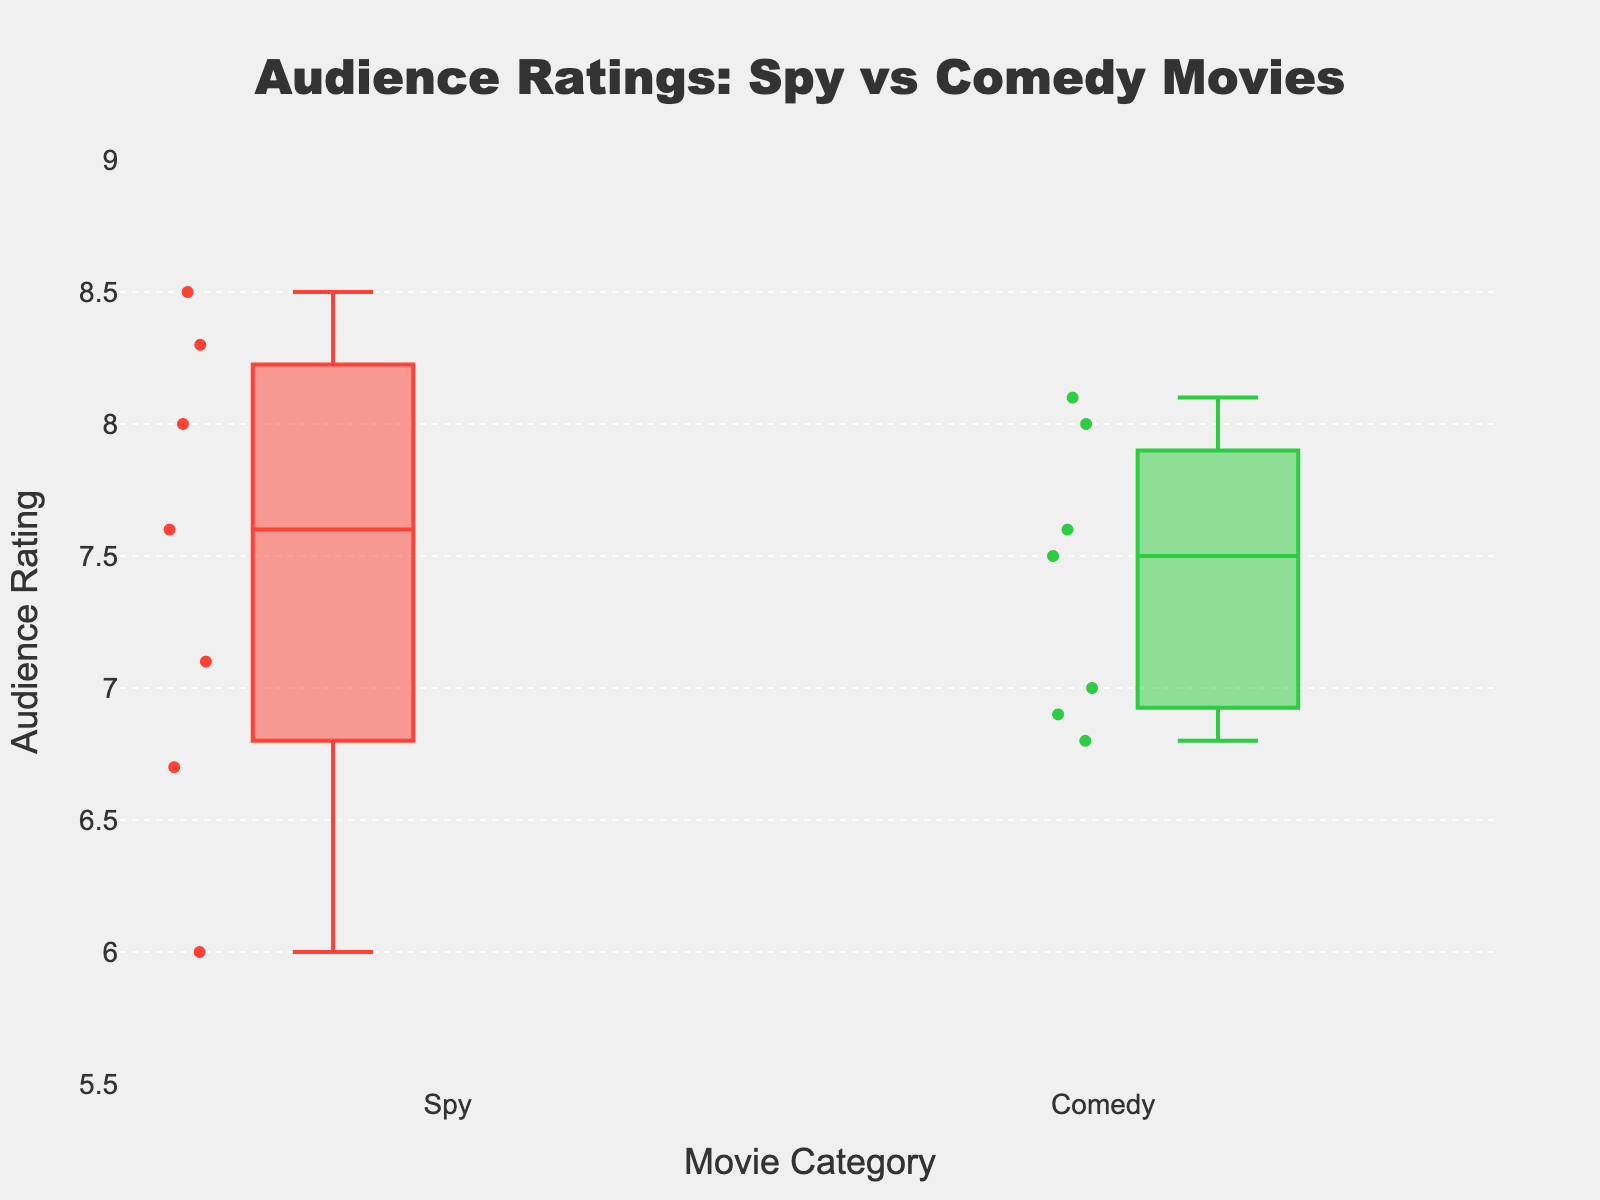What is the title of the figure? The title is usually displayed at the top of the figure, indicating the main focus of the visualization.
Answer: Audience Ratings: Spy vs Comedy Movies What does the y-axis represent in the figure? The y-axis is labeled "Audience Rating," which means it represents the audience rating scores of the movies.
Answer: Audience Rating Which movie category has the highest maximum audience rating? The highest point on the box plot represents the maximum value. For the "Spy" category, it reaches 8.5, whereas for the "Comedy" category, it reaches 8.1.
Answer: Spy What is the median audience rating for spy movies? The median is represented by the line inside the box. For "Spy" movies, it is around 7.1.
Answer: 7.1 What is the difference between the median audience ratings of spy movies and comedy movies? The median for "Spy" movies is 7.1, and for "Comedy" movies, it is around 7.4. The difference is 7.4 - 7.1.
Answer: 0.3 Which movie category has more variability in audience ratings? Variability can be seen in the interquartile range (IQR), which is the length of the box. The "Spy" movies show more variability as the box is taller than the "Comedy" movies' box.
Answer: Spy Are there any outliers in the audience ratings for comedy movies? Outliers in a box plot are shown as individual points outside the whiskers. There are no individual points outside the whiskers for "Comedy" movies.
Answer: No How do the lowest audience ratings of spy and comedy movies compare? The lowest point of the "Spy" movies is at 6.0, while for "Comedy" movies, it is at 6.8. The "Spy" movies category has the lower minimum rating.
Answer: Spy What's the interquartile range (IQR) for comedy movies' audience ratings? The IQR is the range between the first quartile (Q1) and the third quartile (Q3). For "Comedy" movies, Q1 is around 6.9, and Q3 is around 7.8, so the IQR is 7.8 - 6.9 = 0.9.
Answer: 0.9 What's the difference between the highest audience rating for spy and comedy movies? The highest rating for "Spy" movies is 8.5, and for "Comedy" movies, it is 8.1. The difference is 8.5 - 8.1.
Answer: 0.4 